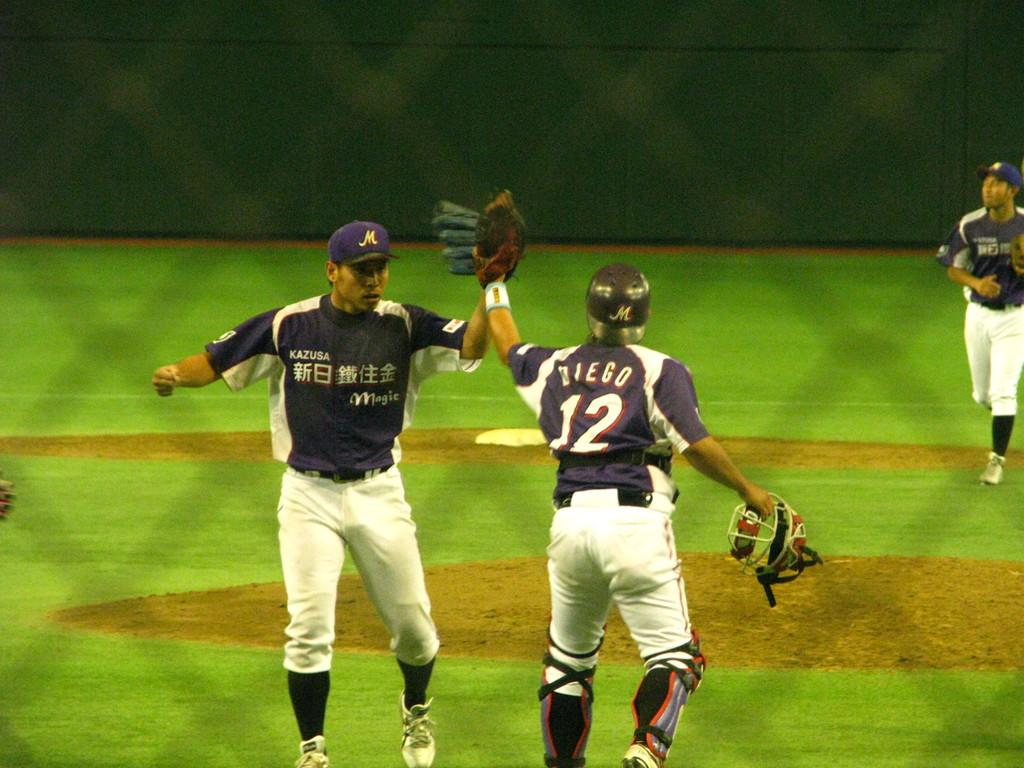<image>
Create a compact narrative representing the image presented. Two baseball players in blue and white uniforms, one with Diego 12 on the back 